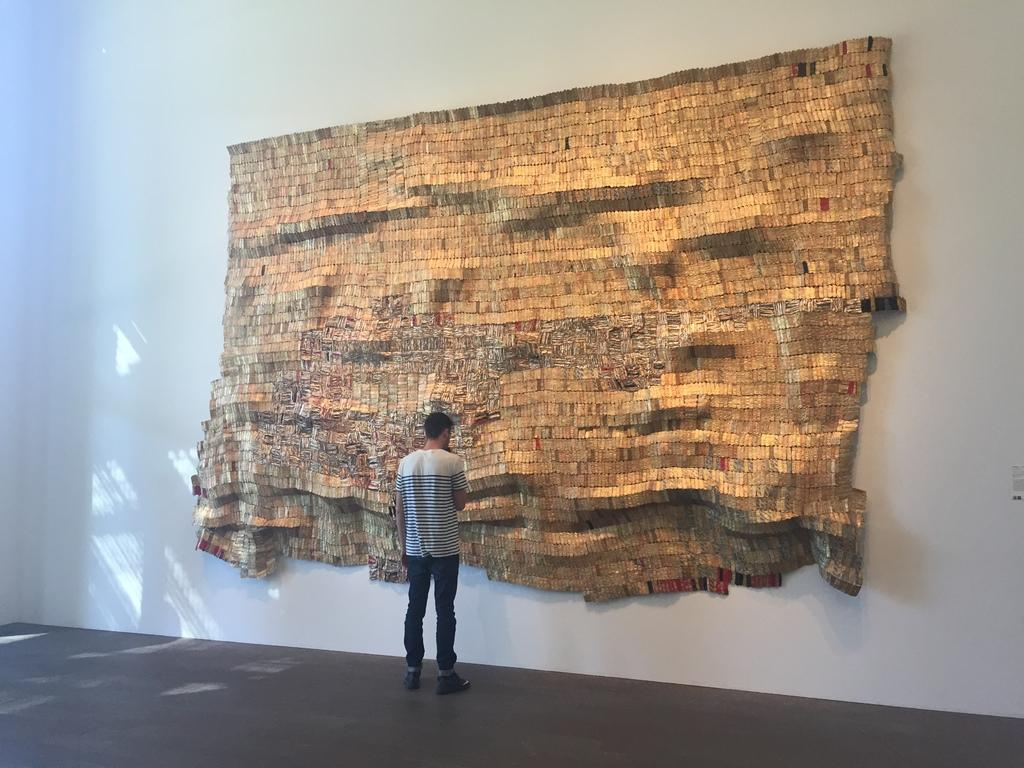What is the main subject of the image? There is a person in the image. Can you describe the position of the person in the image? The person appears to be standing. How is the image presented? The image looks like a sculpture on the wall. How far is the person from the recess in the image? There is no recess present in the image, as it is a sculpture on the wall. 